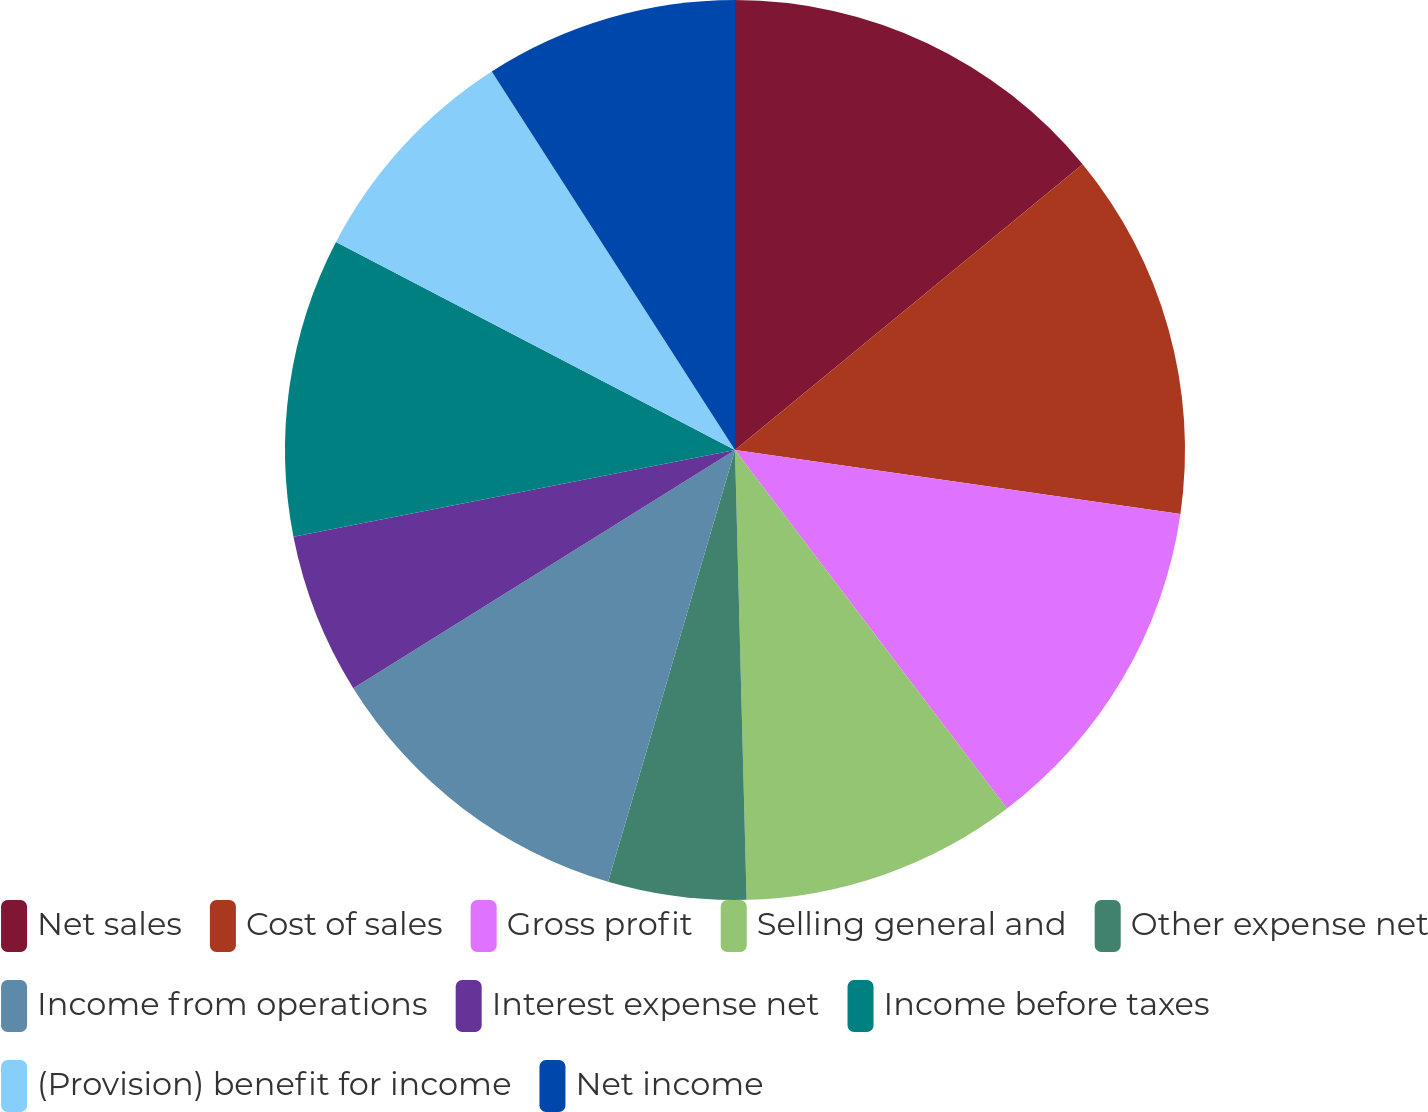Convert chart to OTSL. <chart><loc_0><loc_0><loc_500><loc_500><pie_chart><fcel>Net sales<fcel>Cost of sales<fcel>Gross profit<fcel>Selling general and<fcel>Other expense net<fcel>Income from operations<fcel>Interest expense net<fcel>Income before taxes<fcel>(Provision) benefit for income<fcel>Net income<nl><fcel>14.05%<fcel>13.22%<fcel>12.4%<fcel>9.92%<fcel>4.96%<fcel>11.57%<fcel>5.79%<fcel>10.74%<fcel>8.26%<fcel>9.09%<nl></chart> 